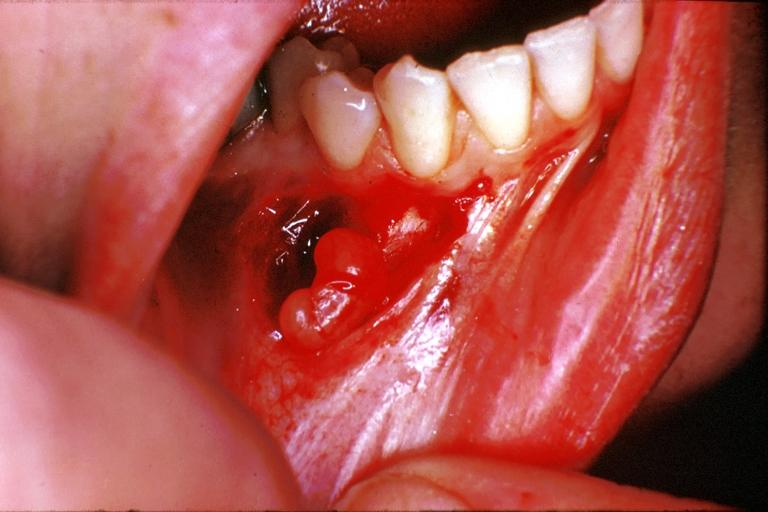s breast present?
Answer the question using a single word or phrase. No 